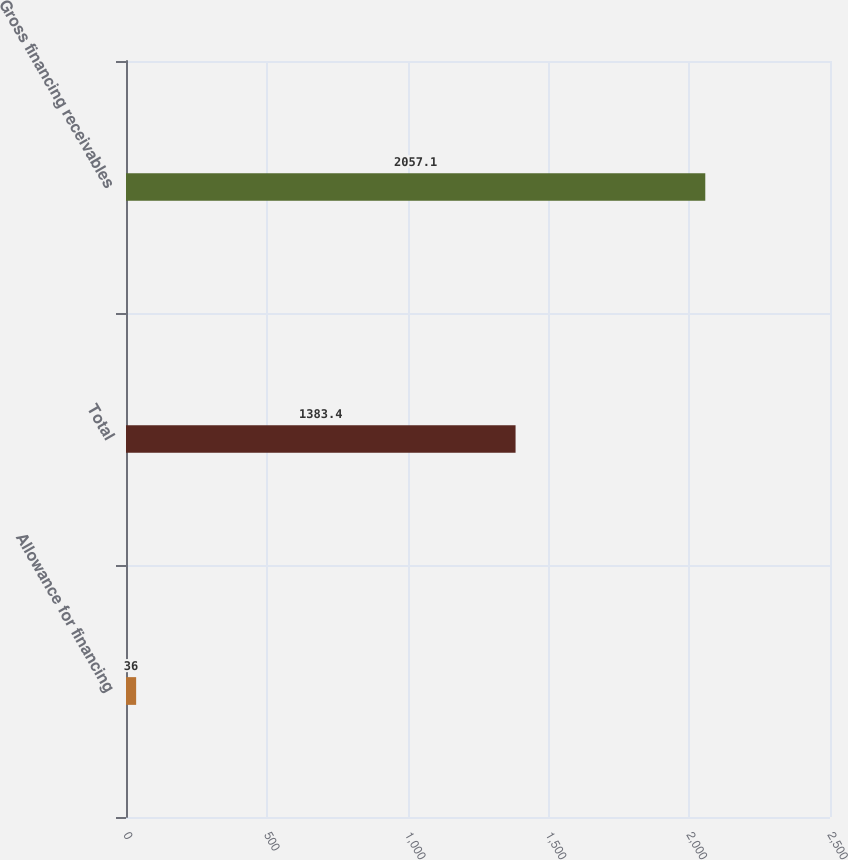<chart> <loc_0><loc_0><loc_500><loc_500><bar_chart><fcel>Allowance for financing<fcel>Total<fcel>Gross financing receivables<nl><fcel>36<fcel>1383.4<fcel>2057.1<nl></chart> 